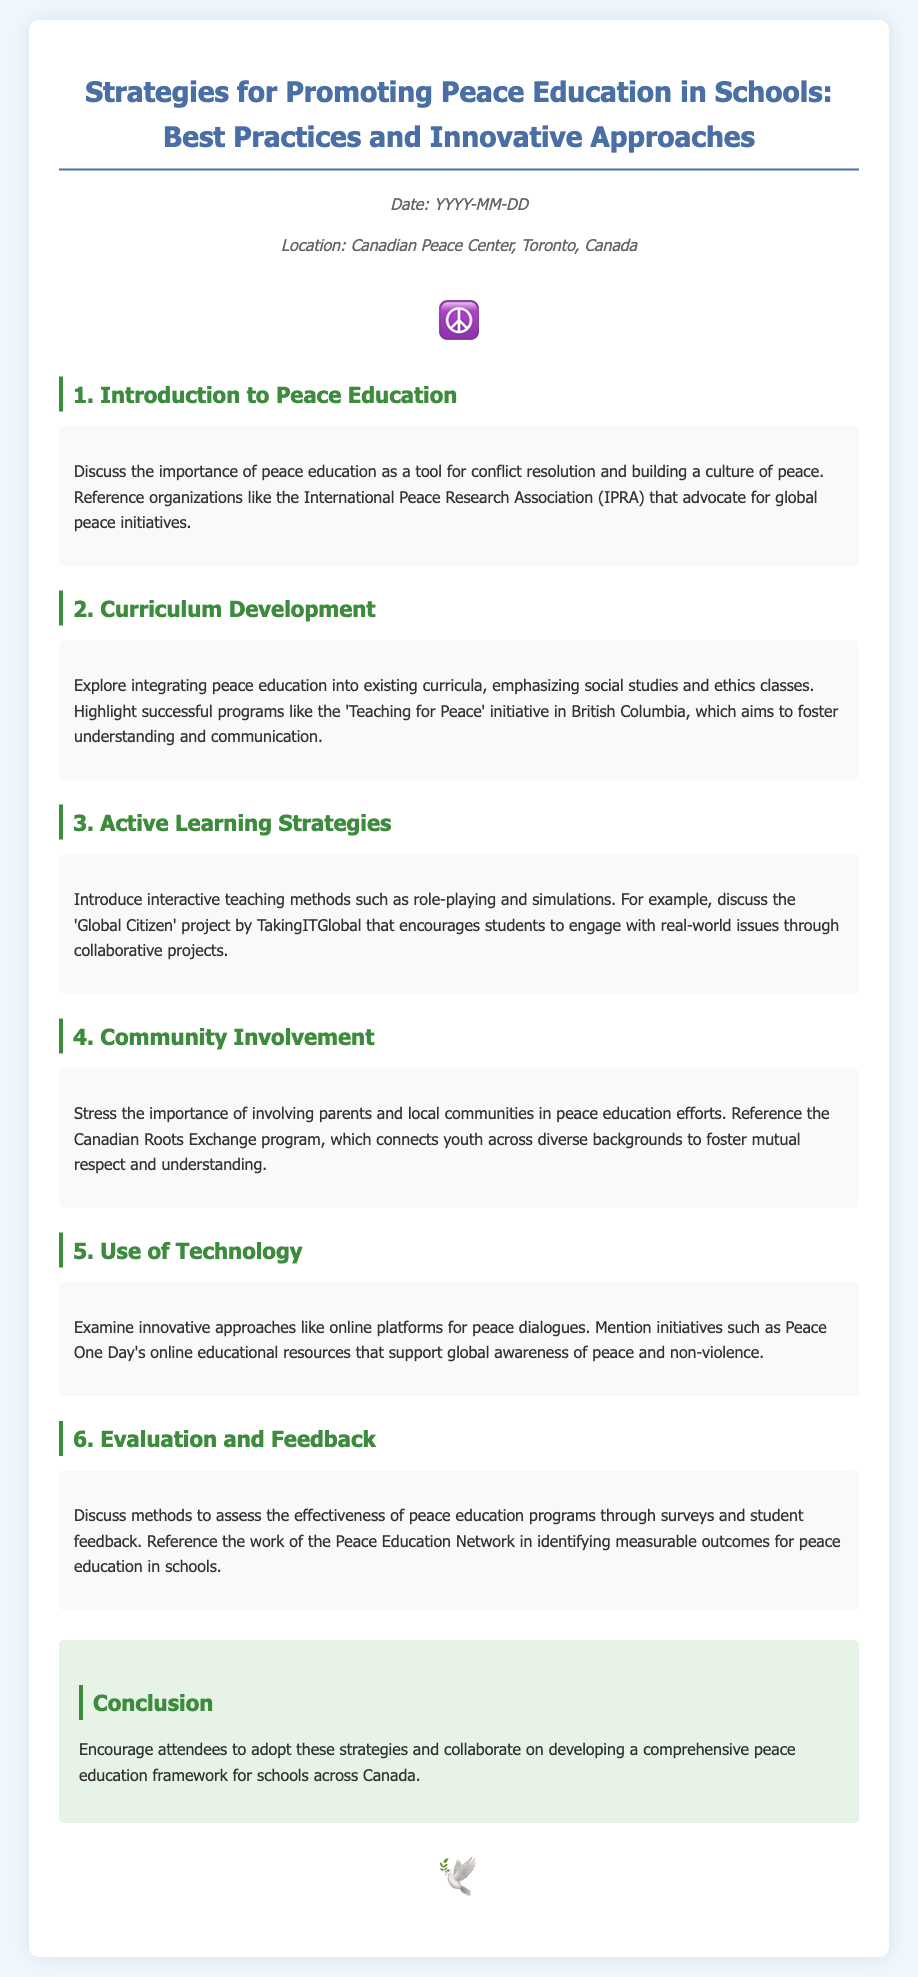What is the title of the document? The title is the heading of the agenda that summarizes its content, which is "Strategies for Promoting Peace Education in Schools: Best Practices and Innovative Approaches."
Answer: Strategies for Promoting Peace Education in Schools: Best Practices and Innovative Approaches What organization is mentioned in the introduction as advocating for global peace initiatives? The introduction refers to the International Peace Research Association (IPRA) as an organization focused on peace initiatives.
Answer: International Peace Research Association (IPRA) Which province's initiative is highlighted for fostering understanding and communication? The document mentions the 'Teaching for Peace' initiative, which is located in British Columbia.
Answer: British Columbia What teaching method is suggested under Active Learning Strategies? The Active Learning Strategies section suggests using role-playing as an interactive teaching method.
Answer: Role-playing What program connects youth across diverse backgrounds for peace education? The document references the Canadian Roots Exchange program as a program that fosters mutual respect and understanding among youth.
Answer: Canadian Roots Exchange What type of resources does Peace One Day offer? Peace One Day provides online educational resources that support global awareness of peace and non-violence.
Answer: Online educational resources What is a suggested method to evaluate peace education programs? The document discusses using surveys and student feedback as methods to assess the effectiveness of peace education programs.
Answer: Surveys and student feedback What is the conclusion urging attendees to do? The conclusion encourages attendees to adopt strategies and collaborate on developing a comprehensive peace education framework.
Answer: Adopt strategies and collaborate on developing a comprehensive peace education framework 